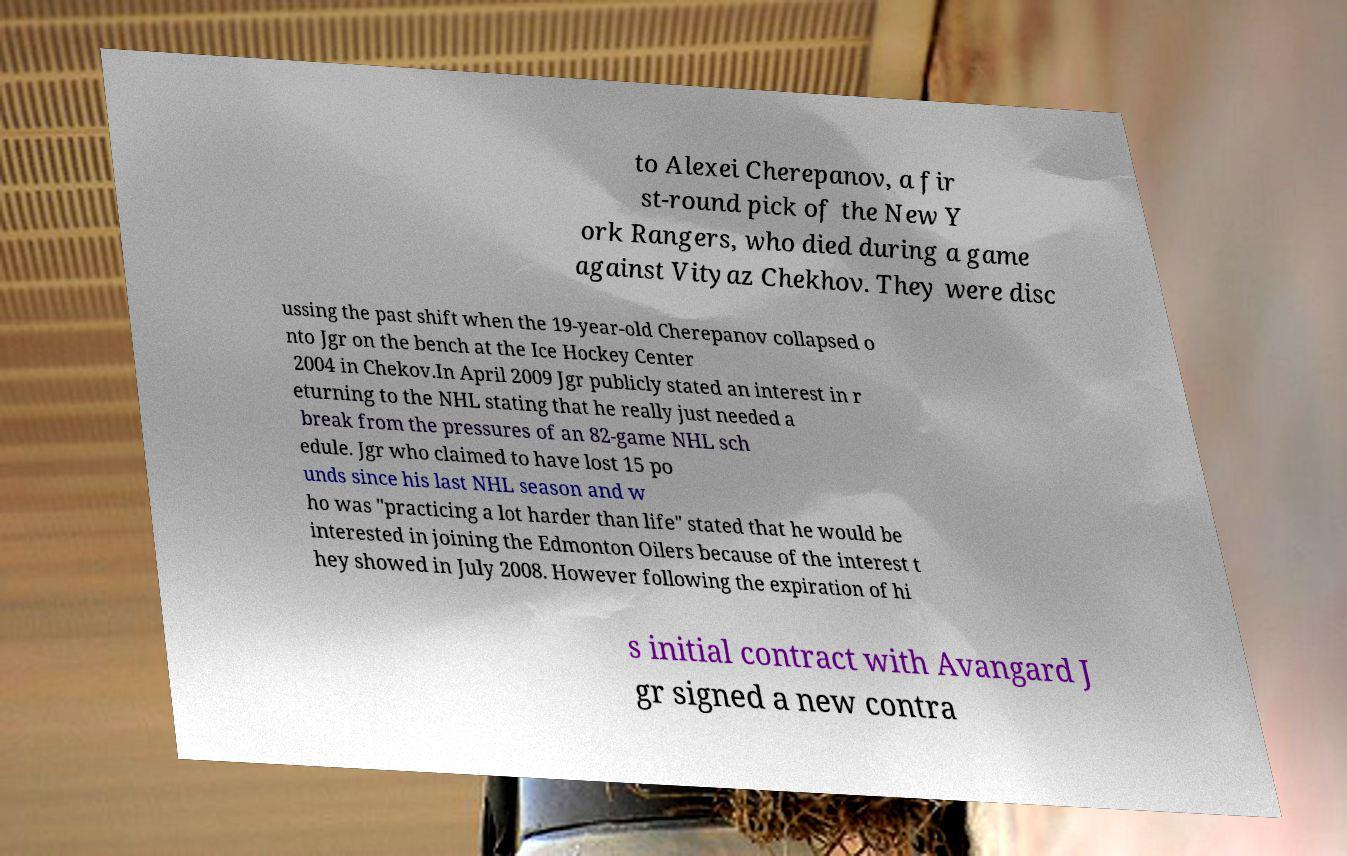Can you read and provide the text displayed in the image?This photo seems to have some interesting text. Can you extract and type it out for me? to Alexei Cherepanov, a fir st-round pick of the New Y ork Rangers, who died during a game against Vityaz Chekhov. They were disc ussing the past shift when the 19-year-old Cherepanov collapsed o nto Jgr on the bench at the Ice Hockey Center 2004 in Chekov.In April 2009 Jgr publicly stated an interest in r eturning to the NHL stating that he really just needed a break from the pressures of an 82-game NHL sch edule. Jgr who claimed to have lost 15 po unds since his last NHL season and w ho was "practicing a lot harder than life" stated that he would be interested in joining the Edmonton Oilers because of the interest t hey showed in July 2008. However following the expiration of hi s initial contract with Avangard J gr signed a new contra 